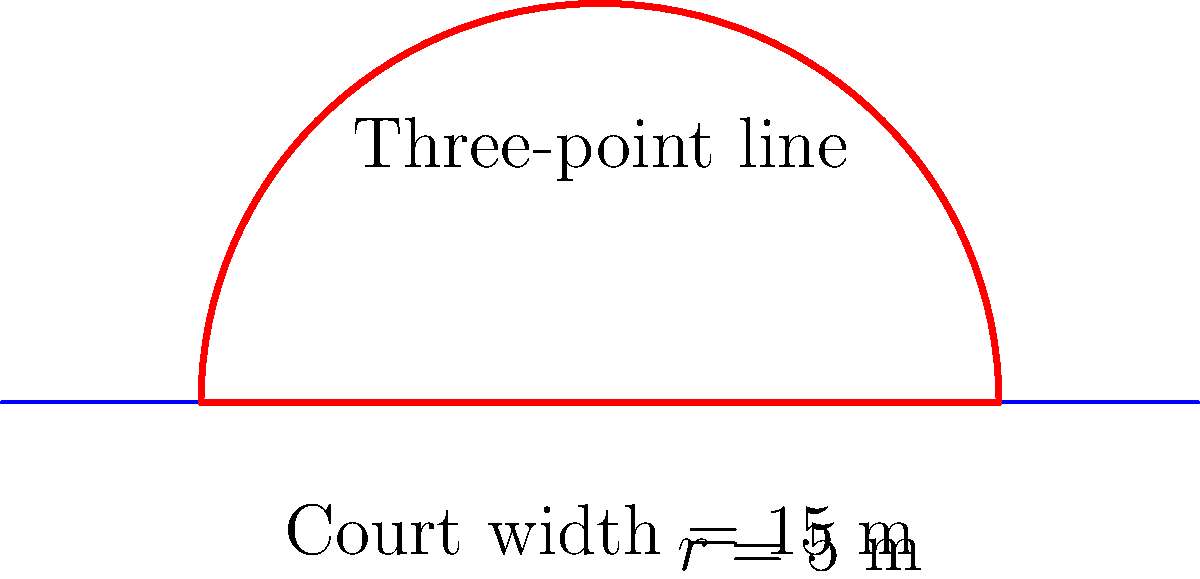On your basketball court, the three-point line forms a semicircle with a radius of 5 meters. If the width of the court is 15 meters, what is the total perimeter of the three-point line, including the straight line connecting the ends of the semicircle? Round your answer to the nearest centimeter. Let's approach this step-by-step:

1) The semicircle forms half of a complete circle. The formula for the circumference of a full circle is $2\pi r$, where $r$ is the radius.

2) For a semicircle, we use half of this formula: $\pi r$

3) Given radius $r = 5$ m, the length of the curved part is:
   $\pi r = \pi \cdot 5 = 5\pi$ meters

4) Now, we need to add the straight line connecting the ends of the semicircle. This is equal to the diameter of the circle, which is twice the radius:
   $2r = 2 \cdot 5 = 10$ meters

5) The total perimeter is the sum of the curved part and the straight part:
   $5\pi + 10$ meters

6) Let's calculate this:
   $5\pi + 10 \approx 15.7079632679 + 10 = 25.7079632679$ meters

7) Rounding to the nearest centimeter (2 decimal places):
   $25.71$ meters
Answer: $25.71$ m 